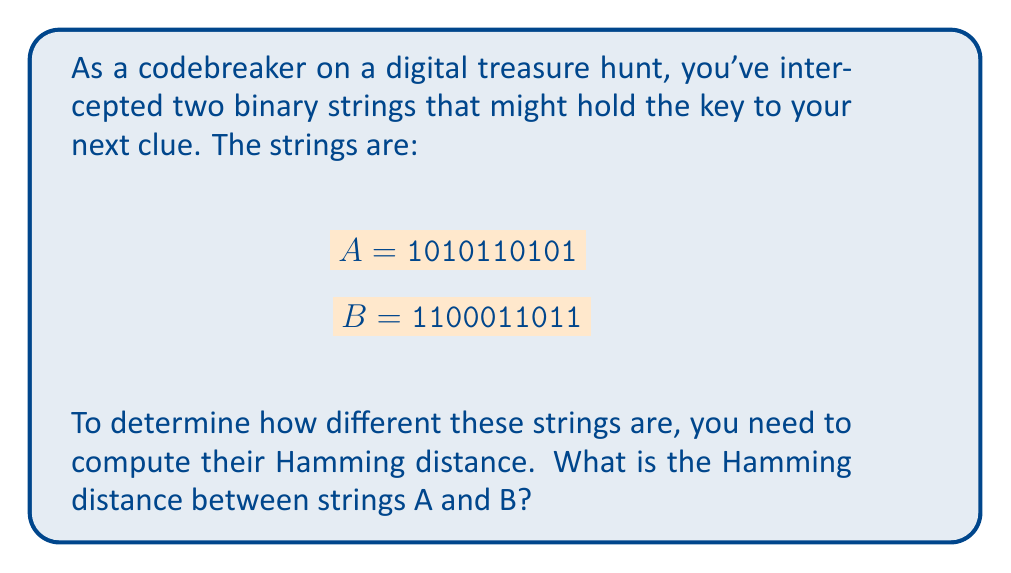Teach me how to tackle this problem. Let's approach this step-by-step:

1) The Hamming distance is defined as the number of positions at which the corresponding symbols in two strings are different.

2) To calculate it, we need to compare each bit of string A with the corresponding bit of string B.

3) Let's align the strings and mark the differences:

   $$\begin{array}{rcl}
   A &=& \color{blue}{1}\color{red}{0}\color{blue}{1}\color{red}{0}\color{blue}{1}\color{red}{1}\color{blue}{0}\color{blue}{1}\color{red}{0}\color{blue}{1} \\
   B &=& \color{blue}{1}\color{red}{1}\color{blue}{0}\color{red}{0}\color{blue}{0}\color{red}{1}\color{blue}{1}\color{blue}{0}\color{red}{1}\color{blue}{1}
   \end{array}$$

4) We can see that the strings differ in 6 positions (marked in red).

5) Therefore, the Hamming distance between A and B is 6.

This Hamming distance of 6 indicates a significant difference between the two strings, which might be crucial for decoding the next clue in your digital treasure hunt.
Answer: 6 